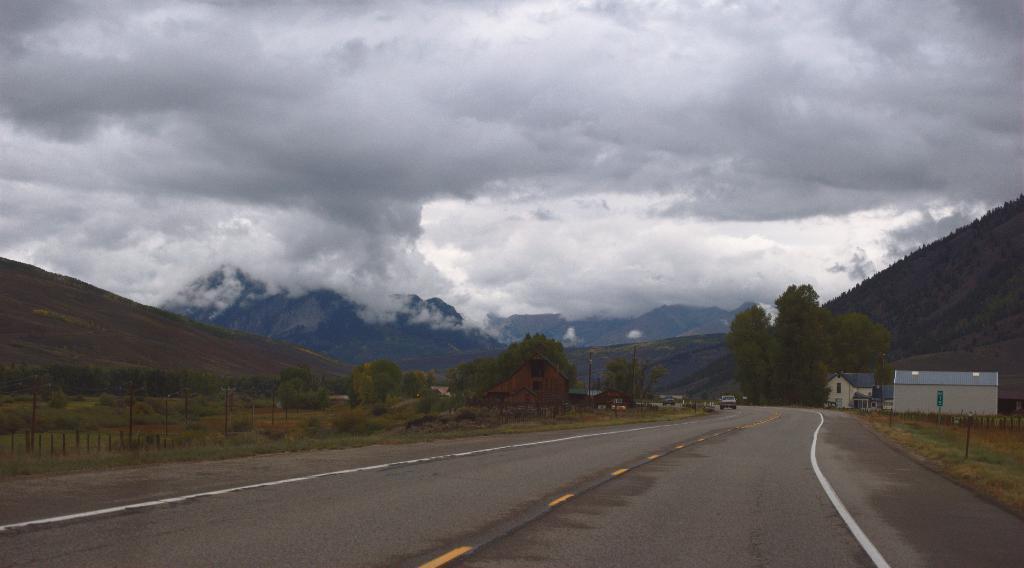How would you summarize this image in a sentence or two? In the picture I can see the road, a car moving on the road, I can see houses, grasslands, trees, hills and the cloudy sky in the background. 